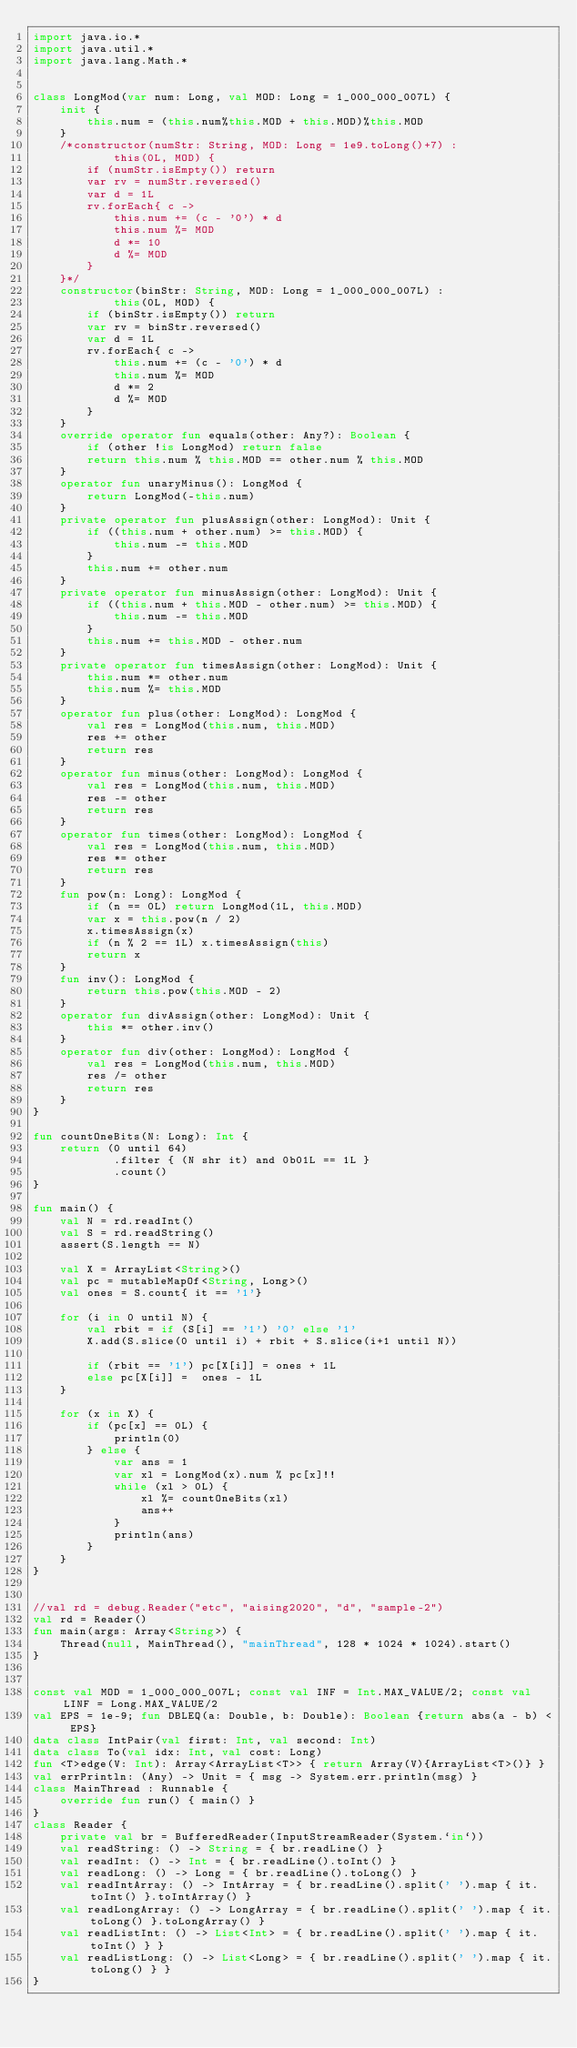Convert code to text. <code><loc_0><loc_0><loc_500><loc_500><_Kotlin_>import java.io.*
import java.util.*
import java.lang.Math.*


class LongMod(var num: Long, val MOD: Long = 1_000_000_007L) {
    init {
        this.num = (this.num%this.MOD + this.MOD)%this.MOD
    }
    /*constructor(numStr: String, MOD: Long = 1e9.toLong()+7) :
            this(0L, MOD) {
        if (numStr.isEmpty()) return
        var rv = numStr.reversed()
        var d = 1L
        rv.forEach{ c ->
            this.num += (c - '0') * d
            this.num %= MOD
            d *= 10
            d %= MOD
        }
    }*/
    constructor(binStr: String, MOD: Long = 1_000_000_007L) :
            this(0L, MOD) {
        if (binStr.isEmpty()) return
        var rv = binStr.reversed()
        var d = 1L
        rv.forEach{ c ->
            this.num += (c - '0') * d
            this.num %= MOD
            d *= 2
            d %= MOD
        }
    }
    override operator fun equals(other: Any?): Boolean {
        if (other !is LongMod) return false
        return this.num % this.MOD == other.num % this.MOD
    }
    operator fun unaryMinus(): LongMod {
        return LongMod(-this.num)
    }
    private operator fun plusAssign(other: LongMod): Unit {
        if ((this.num + other.num) >= this.MOD) {
            this.num -= this.MOD
        }
        this.num += other.num
    }
    private operator fun minusAssign(other: LongMod): Unit {
        if ((this.num + this.MOD - other.num) >= this.MOD) {
            this.num -= this.MOD
        }
        this.num += this.MOD - other.num
    }
    private operator fun timesAssign(other: LongMod): Unit {
        this.num *= other.num
        this.num %= this.MOD
    }
    operator fun plus(other: LongMod): LongMod {
        val res = LongMod(this.num, this.MOD)
        res += other
        return res
    }
    operator fun minus(other: LongMod): LongMod {
        val res = LongMod(this.num, this.MOD)
        res -= other
        return res
    }
    operator fun times(other: LongMod): LongMod {
        val res = LongMod(this.num, this.MOD)
        res *= other
        return res
    }
    fun pow(n: Long): LongMod {
        if (n == 0L) return LongMod(1L, this.MOD)
        var x = this.pow(n / 2)
        x.timesAssign(x)
        if (n % 2 == 1L) x.timesAssign(this)
        return x
    }
    fun inv(): LongMod {
        return this.pow(this.MOD - 2)
    }
    operator fun divAssign(other: LongMod): Unit {
        this *= other.inv()
    }
    operator fun div(other: LongMod): LongMod {
        val res = LongMod(this.num, this.MOD)
        res /= other
        return res
    }
}

fun countOneBits(N: Long): Int {
    return (0 until 64)
            .filter { (N shr it) and 0b01L == 1L }
            .count()
}

fun main() {
    val N = rd.readInt()
    val S = rd.readString()
    assert(S.length == N)

    val X = ArrayList<String>()
    val pc = mutableMapOf<String, Long>()
    val ones = S.count{ it == '1'}

    for (i in 0 until N) {
        val rbit = if (S[i] == '1') '0' else '1'
        X.add(S.slice(0 until i) + rbit + S.slice(i+1 until N))

        if (rbit == '1') pc[X[i]] = ones + 1L
        else pc[X[i]] =  ones - 1L
    }

    for (x in X) {
        if (pc[x] == 0L) {
            println(0)
        } else {
            var ans = 1
            var xl = LongMod(x).num % pc[x]!!
            while (xl > 0L) {
                xl %= countOneBits(xl)
                ans++
            }
            println(ans)
        }
    }
}


//val rd = debug.Reader("etc", "aising2020", "d", "sample-2")
val rd = Reader()
fun main(args: Array<String>) {
    Thread(null, MainThread(), "mainThread", 128 * 1024 * 1024).start()
}


const val MOD = 1_000_000_007L; const val INF = Int.MAX_VALUE/2; const val LINF = Long.MAX_VALUE/2
val EPS = 1e-9; fun DBLEQ(a: Double, b: Double): Boolean {return abs(a - b) < EPS}
data class IntPair(val first: Int, val second: Int)
data class To(val idx: Int, val cost: Long)
fun <T>edge(V: Int): Array<ArrayList<T>> { return Array(V){ArrayList<T>()} }
val errPrintln: (Any) -> Unit = { msg -> System.err.println(msg) }
class MainThread : Runnable {
    override fun run() { main() }
}
class Reader {
    private val br = BufferedReader(InputStreamReader(System.`in`))
    val readString: () -> String = { br.readLine() }
    val readInt: () -> Int = { br.readLine().toInt() }
    val readLong: () -> Long = { br.readLine().toLong() }
    val readIntArray: () -> IntArray = { br.readLine().split(' ').map { it.toInt() }.toIntArray() }
    val readLongArray: () -> LongArray = { br.readLine().split(' ').map { it.toLong() }.toLongArray() }
    val readListInt: () -> List<Int> = { br.readLine().split(' ').map { it.toInt() } }
    val readListLong: () -> List<Long> = { br.readLine().split(' ').map { it.toLong() } }
}
</code> 